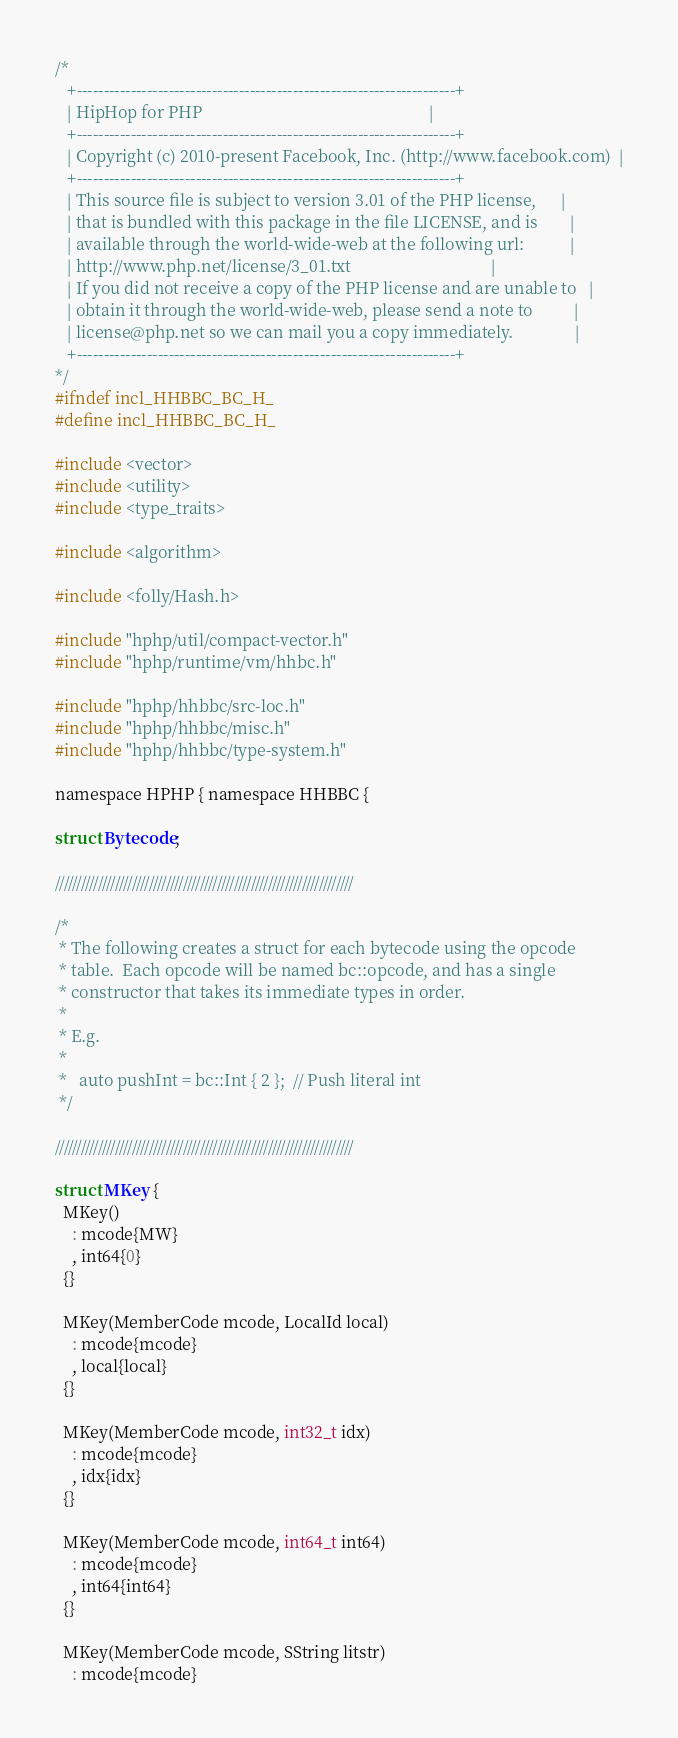<code> <loc_0><loc_0><loc_500><loc_500><_C_>/*
   +----------------------------------------------------------------------+
   | HipHop for PHP                                                       |
   +----------------------------------------------------------------------+
   | Copyright (c) 2010-present Facebook, Inc. (http://www.facebook.com)  |
   +----------------------------------------------------------------------+
   | This source file is subject to version 3.01 of the PHP license,      |
   | that is bundled with this package in the file LICENSE, and is        |
   | available through the world-wide-web at the following url:           |
   | http://www.php.net/license/3_01.txt                                  |
   | If you did not receive a copy of the PHP license and are unable to   |
   | obtain it through the world-wide-web, please send a note to          |
   | license@php.net so we can mail you a copy immediately.               |
   +----------------------------------------------------------------------+
*/
#ifndef incl_HHBBC_BC_H_
#define incl_HHBBC_BC_H_

#include <vector>
#include <utility>
#include <type_traits>

#include <algorithm>

#include <folly/Hash.h>

#include "hphp/util/compact-vector.h"
#include "hphp/runtime/vm/hhbc.h"

#include "hphp/hhbbc/src-loc.h"
#include "hphp/hhbbc/misc.h"
#include "hphp/hhbbc/type-system.h"

namespace HPHP { namespace HHBBC {

struct Bytecode;

//////////////////////////////////////////////////////////////////////

/*
 * The following creates a struct for each bytecode using the opcode
 * table.  Each opcode will be named bc::opcode, and has a single
 * constructor that takes its immediate types in order.
 *
 * E.g.
 *
 *   auto pushInt = bc::Int { 2 };  // Push literal int
 */

//////////////////////////////////////////////////////////////////////

struct MKey {
  MKey()
    : mcode{MW}
    , int64{0}
  {}

  MKey(MemberCode mcode, LocalId local)
    : mcode{mcode}
    , local{local}
  {}

  MKey(MemberCode mcode, int32_t idx)
    : mcode{mcode}
    , idx{idx}
  {}

  MKey(MemberCode mcode, int64_t int64)
    : mcode{mcode}
    , int64{int64}
  {}

  MKey(MemberCode mcode, SString litstr)
    : mcode{mcode}</code> 